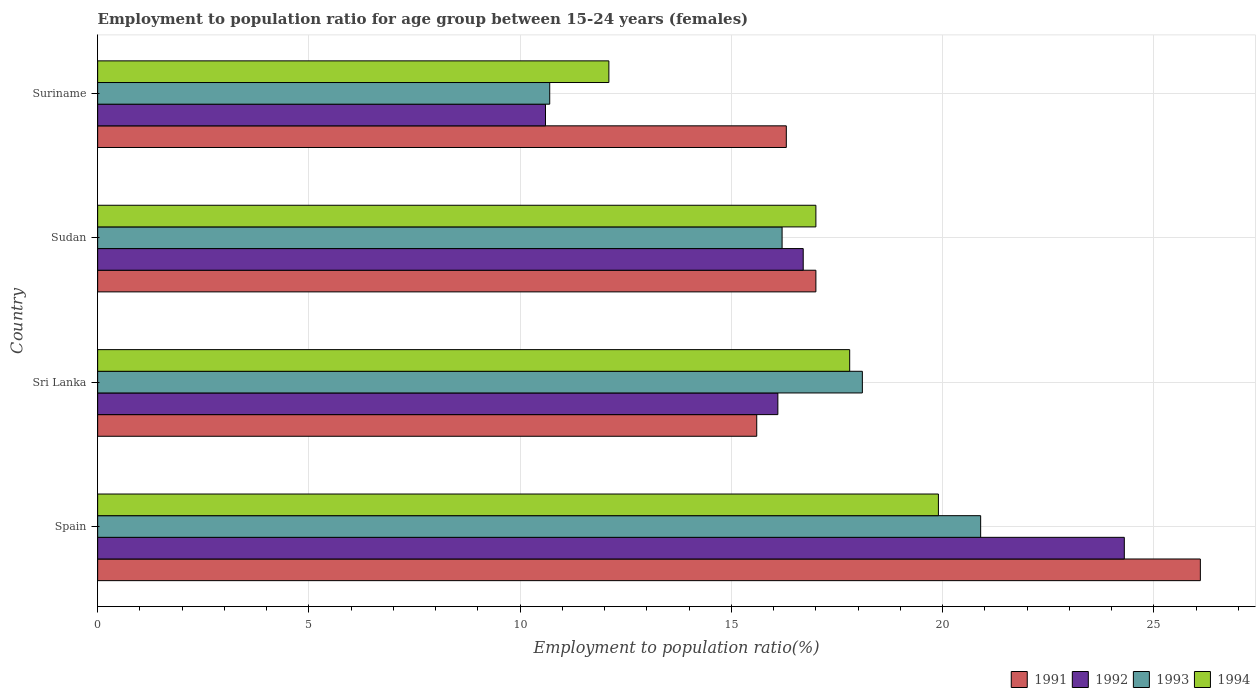How many different coloured bars are there?
Offer a very short reply. 4. Are the number of bars on each tick of the Y-axis equal?
Give a very brief answer. Yes. What is the label of the 2nd group of bars from the top?
Your response must be concise. Sudan. In how many cases, is the number of bars for a given country not equal to the number of legend labels?
Provide a succinct answer. 0. What is the employment to population ratio in 1994 in Sri Lanka?
Ensure brevity in your answer.  17.8. Across all countries, what is the maximum employment to population ratio in 1991?
Provide a succinct answer. 26.1. Across all countries, what is the minimum employment to population ratio in 1991?
Your answer should be compact. 15.6. In which country was the employment to population ratio in 1994 maximum?
Your answer should be compact. Spain. In which country was the employment to population ratio in 1994 minimum?
Offer a very short reply. Suriname. What is the total employment to population ratio in 1992 in the graph?
Make the answer very short. 67.7. What is the difference between the employment to population ratio in 1993 in Spain and that in Sri Lanka?
Ensure brevity in your answer.  2.8. What is the difference between the employment to population ratio in 1991 in Sri Lanka and the employment to population ratio in 1992 in Spain?
Give a very brief answer. -8.7. What is the average employment to population ratio in 1993 per country?
Give a very brief answer. 16.48. What is the difference between the employment to population ratio in 1993 and employment to population ratio in 1994 in Suriname?
Make the answer very short. -1.4. What is the ratio of the employment to population ratio in 1994 in Sudan to that in Suriname?
Ensure brevity in your answer.  1.4. Is the employment to population ratio in 1994 in Spain less than that in Sudan?
Your answer should be very brief. No. What is the difference between the highest and the second highest employment to population ratio in 1993?
Your answer should be very brief. 2.8. What is the difference between the highest and the lowest employment to population ratio in 1991?
Provide a succinct answer. 10.5. What does the 2nd bar from the bottom in Sri Lanka represents?
Your response must be concise. 1992. Are all the bars in the graph horizontal?
Your answer should be compact. Yes. How many countries are there in the graph?
Provide a succinct answer. 4. Does the graph contain grids?
Ensure brevity in your answer.  Yes. Where does the legend appear in the graph?
Offer a terse response. Bottom right. How are the legend labels stacked?
Keep it short and to the point. Horizontal. What is the title of the graph?
Give a very brief answer. Employment to population ratio for age group between 15-24 years (females). What is the label or title of the X-axis?
Provide a short and direct response. Employment to population ratio(%). What is the Employment to population ratio(%) of 1991 in Spain?
Offer a very short reply. 26.1. What is the Employment to population ratio(%) in 1992 in Spain?
Make the answer very short. 24.3. What is the Employment to population ratio(%) in 1993 in Spain?
Make the answer very short. 20.9. What is the Employment to population ratio(%) in 1994 in Spain?
Provide a short and direct response. 19.9. What is the Employment to population ratio(%) in 1991 in Sri Lanka?
Ensure brevity in your answer.  15.6. What is the Employment to population ratio(%) of 1992 in Sri Lanka?
Make the answer very short. 16.1. What is the Employment to population ratio(%) in 1993 in Sri Lanka?
Keep it short and to the point. 18.1. What is the Employment to population ratio(%) of 1994 in Sri Lanka?
Make the answer very short. 17.8. What is the Employment to population ratio(%) in 1991 in Sudan?
Make the answer very short. 17. What is the Employment to population ratio(%) of 1992 in Sudan?
Keep it short and to the point. 16.7. What is the Employment to population ratio(%) in 1993 in Sudan?
Make the answer very short. 16.2. What is the Employment to population ratio(%) of 1991 in Suriname?
Make the answer very short. 16.3. What is the Employment to population ratio(%) of 1992 in Suriname?
Keep it short and to the point. 10.6. What is the Employment to population ratio(%) of 1993 in Suriname?
Your answer should be compact. 10.7. What is the Employment to population ratio(%) of 1994 in Suriname?
Provide a short and direct response. 12.1. Across all countries, what is the maximum Employment to population ratio(%) in 1991?
Provide a short and direct response. 26.1. Across all countries, what is the maximum Employment to population ratio(%) of 1992?
Give a very brief answer. 24.3. Across all countries, what is the maximum Employment to population ratio(%) of 1993?
Make the answer very short. 20.9. Across all countries, what is the maximum Employment to population ratio(%) in 1994?
Offer a very short reply. 19.9. Across all countries, what is the minimum Employment to population ratio(%) of 1991?
Ensure brevity in your answer.  15.6. Across all countries, what is the minimum Employment to population ratio(%) of 1992?
Keep it short and to the point. 10.6. Across all countries, what is the minimum Employment to population ratio(%) in 1993?
Provide a succinct answer. 10.7. Across all countries, what is the minimum Employment to population ratio(%) in 1994?
Provide a succinct answer. 12.1. What is the total Employment to population ratio(%) of 1991 in the graph?
Offer a very short reply. 75. What is the total Employment to population ratio(%) of 1992 in the graph?
Provide a succinct answer. 67.7. What is the total Employment to population ratio(%) of 1993 in the graph?
Ensure brevity in your answer.  65.9. What is the total Employment to population ratio(%) of 1994 in the graph?
Keep it short and to the point. 66.8. What is the difference between the Employment to population ratio(%) in 1991 in Spain and that in Sudan?
Your response must be concise. 9.1. What is the difference between the Employment to population ratio(%) in 1992 in Spain and that in Sudan?
Provide a short and direct response. 7.6. What is the difference between the Employment to population ratio(%) in 1993 in Spain and that in Sudan?
Offer a very short reply. 4.7. What is the difference between the Employment to population ratio(%) in 1994 in Spain and that in Sudan?
Provide a succinct answer. 2.9. What is the difference between the Employment to population ratio(%) of 1991 in Spain and that in Suriname?
Provide a succinct answer. 9.8. What is the difference between the Employment to population ratio(%) of 1993 in Spain and that in Suriname?
Provide a succinct answer. 10.2. What is the difference between the Employment to population ratio(%) in 1994 in Spain and that in Suriname?
Offer a terse response. 7.8. What is the difference between the Employment to population ratio(%) of 1991 in Sri Lanka and that in Sudan?
Keep it short and to the point. -1.4. What is the difference between the Employment to population ratio(%) of 1991 in Sudan and that in Suriname?
Provide a succinct answer. 0.7. What is the difference between the Employment to population ratio(%) in 1992 in Sudan and that in Suriname?
Offer a very short reply. 6.1. What is the difference between the Employment to population ratio(%) of 1993 in Sudan and that in Suriname?
Provide a short and direct response. 5.5. What is the difference between the Employment to population ratio(%) in 1994 in Sudan and that in Suriname?
Your answer should be very brief. 4.9. What is the difference between the Employment to population ratio(%) of 1991 in Spain and the Employment to population ratio(%) of 1992 in Sri Lanka?
Make the answer very short. 10. What is the difference between the Employment to population ratio(%) of 1991 in Spain and the Employment to population ratio(%) of 1994 in Sri Lanka?
Your answer should be compact. 8.3. What is the difference between the Employment to population ratio(%) of 1992 in Spain and the Employment to population ratio(%) of 1993 in Sri Lanka?
Provide a short and direct response. 6.2. What is the difference between the Employment to population ratio(%) of 1992 in Spain and the Employment to population ratio(%) of 1994 in Sri Lanka?
Provide a succinct answer. 6.5. What is the difference between the Employment to population ratio(%) in 1991 in Spain and the Employment to population ratio(%) in 1994 in Sudan?
Offer a very short reply. 9.1. What is the difference between the Employment to population ratio(%) of 1992 in Spain and the Employment to population ratio(%) of 1993 in Sudan?
Offer a very short reply. 8.1. What is the difference between the Employment to population ratio(%) in 1993 in Spain and the Employment to population ratio(%) in 1994 in Sudan?
Offer a terse response. 3.9. What is the difference between the Employment to population ratio(%) of 1991 in Spain and the Employment to population ratio(%) of 1992 in Suriname?
Your response must be concise. 15.5. What is the difference between the Employment to population ratio(%) in 1991 in Spain and the Employment to population ratio(%) in 1993 in Suriname?
Offer a very short reply. 15.4. What is the difference between the Employment to population ratio(%) in 1991 in Spain and the Employment to population ratio(%) in 1994 in Suriname?
Your answer should be compact. 14. What is the difference between the Employment to population ratio(%) in 1993 in Spain and the Employment to population ratio(%) in 1994 in Suriname?
Ensure brevity in your answer.  8.8. What is the difference between the Employment to population ratio(%) of 1991 in Sri Lanka and the Employment to population ratio(%) of 1992 in Sudan?
Provide a succinct answer. -1.1. What is the difference between the Employment to population ratio(%) of 1991 in Sri Lanka and the Employment to population ratio(%) of 1994 in Sudan?
Offer a very short reply. -1.4. What is the difference between the Employment to population ratio(%) of 1992 in Sri Lanka and the Employment to population ratio(%) of 1993 in Sudan?
Provide a succinct answer. -0.1. What is the difference between the Employment to population ratio(%) of 1993 in Sri Lanka and the Employment to population ratio(%) of 1994 in Sudan?
Keep it short and to the point. 1.1. What is the difference between the Employment to population ratio(%) in 1991 in Sri Lanka and the Employment to population ratio(%) in 1993 in Suriname?
Ensure brevity in your answer.  4.9. What is the difference between the Employment to population ratio(%) in 1991 in Sri Lanka and the Employment to population ratio(%) in 1994 in Suriname?
Your response must be concise. 3.5. What is the difference between the Employment to population ratio(%) of 1992 in Sri Lanka and the Employment to population ratio(%) of 1994 in Suriname?
Offer a very short reply. 4. What is the difference between the Employment to population ratio(%) in 1991 in Sudan and the Employment to population ratio(%) in 1992 in Suriname?
Ensure brevity in your answer.  6.4. What is the difference between the Employment to population ratio(%) in 1991 in Sudan and the Employment to population ratio(%) in 1993 in Suriname?
Offer a terse response. 6.3. What is the difference between the Employment to population ratio(%) of 1991 in Sudan and the Employment to population ratio(%) of 1994 in Suriname?
Give a very brief answer. 4.9. What is the difference between the Employment to population ratio(%) of 1992 in Sudan and the Employment to population ratio(%) of 1994 in Suriname?
Give a very brief answer. 4.6. What is the average Employment to population ratio(%) of 1991 per country?
Your answer should be compact. 18.75. What is the average Employment to population ratio(%) of 1992 per country?
Your response must be concise. 16.93. What is the average Employment to population ratio(%) of 1993 per country?
Your answer should be compact. 16.48. What is the difference between the Employment to population ratio(%) in 1991 and Employment to population ratio(%) in 1992 in Spain?
Offer a terse response. 1.8. What is the difference between the Employment to population ratio(%) in 1991 and Employment to population ratio(%) in 1994 in Spain?
Provide a short and direct response. 6.2. What is the difference between the Employment to population ratio(%) of 1992 and Employment to population ratio(%) of 1994 in Spain?
Make the answer very short. 4.4. What is the difference between the Employment to population ratio(%) in 1991 and Employment to population ratio(%) in 1992 in Sri Lanka?
Provide a short and direct response. -0.5. What is the difference between the Employment to population ratio(%) in 1991 and Employment to population ratio(%) in 1993 in Sri Lanka?
Give a very brief answer. -2.5. What is the difference between the Employment to population ratio(%) in 1992 and Employment to population ratio(%) in 1993 in Sri Lanka?
Your response must be concise. -2. What is the difference between the Employment to population ratio(%) in 1992 and Employment to population ratio(%) in 1994 in Sri Lanka?
Your answer should be very brief. -1.7. What is the difference between the Employment to population ratio(%) of 1991 and Employment to population ratio(%) of 1992 in Sudan?
Give a very brief answer. 0.3. What is the difference between the Employment to population ratio(%) in 1991 and Employment to population ratio(%) in 1993 in Sudan?
Your answer should be compact. 0.8. What is the difference between the Employment to population ratio(%) in 1991 and Employment to population ratio(%) in 1994 in Sudan?
Give a very brief answer. 0. What is the difference between the Employment to population ratio(%) of 1992 and Employment to population ratio(%) of 1993 in Sudan?
Ensure brevity in your answer.  0.5. What is the difference between the Employment to population ratio(%) in 1991 and Employment to population ratio(%) in 1992 in Suriname?
Make the answer very short. 5.7. What is the difference between the Employment to population ratio(%) of 1991 and Employment to population ratio(%) of 1993 in Suriname?
Your answer should be very brief. 5.6. What is the ratio of the Employment to population ratio(%) of 1991 in Spain to that in Sri Lanka?
Your answer should be very brief. 1.67. What is the ratio of the Employment to population ratio(%) of 1992 in Spain to that in Sri Lanka?
Offer a terse response. 1.51. What is the ratio of the Employment to population ratio(%) in 1993 in Spain to that in Sri Lanka?
Ensure brevity in your answer.  1.15. What is the ratio of the Employment to population ratio(%) in 1994 in Spain to that in Sri Lanka?
Offer a very short reply. 1.12. What is the ratio of the Employment to population ratio(%) in 1991 in Spain to that in Sudan?
Your answer should be very brief. 1.54. What is the ratio of the Employment to population ratio(%) of 1992 in Spain to that in Sudan?
Ensure brevity in your answer.  1.46. What is the ratio of the Employment to population ratio(%) in 1993 in Spain to that in Sudan?
Offer a very short reply. 1.29. What is the ratio of the Employment to population ratio(%) of 1994 in Spain to that in Sudan?
Provide a short and direct response. 1.17. What is the ratio of the Employment to population ratio(%) of 1991 in Spain to that in Suriname?
Provide a succinct answer. 1.6. What is the ratio of the Employment to population ratio(%) of 1992 in Spain to that in Suriname?
Your answer should be very brief. 2.29. What is the ratio of the Employment to population ratio(%) in 1993 in Spain to that in Suriname?
Your answer should be very brief. 1.95. What is the ratio of the Employment to population ratio(%) in 1994 in Spain to that in Suriname?
Offer a terse response. 1.64. What is the ratio of the Employment to population ratio(%) in 1991 in Sri Lanka to that in Sudan?
Offer a very short reply. 0.92. What is the ratio of the Employment to population ratio(%) of 1992 in Sri Lanka to that in Sudan?
Make the answer very short. 0.96. What is the ratio of the Employment to population ratio(%) in 1993 in Sri Lanka to that in Sudan?
Provide a short and direct response. 1.12. What is the ratio of the Employment to population ratio(%) in 1994 in Sri Lanka to that in Sudan?
Your response must be concise. 1.05. What is the ratio of the Employment to population ratio(%) of 1991 in Sri Lanka to that in Suriname?
Your response must be concise. 0.96. What is the ratio of the Employment to population ratio(%) of 1992 in Sri Lanka to that in Suriname?
Ensure brevity in your answer.  1.52. What is the ratio of the Employment to population ratio(%) of 1993 in Sri Lanka to that in Suriname?
Provide a succinct answer. 1.69. What is the ratio of the Employment to population ratio(%) of 1994 in Sri Lanka to that in Suriname?
Your response must be concise. 1.47. What is the ratio of the Employment to population ratio(%) in 1991 in Sudan to that in Suriname?
Keep it short and to the point. 1.04. What is the ratio of the Employment to population ratio(%) in 1992 in Sudan to that in Suriname?
Make the answer very short. 1.58. What is the ratio of the Employment to population ratio(%) of 1993 in Sudan to that in Suriname?
Offer a very short reply. 1.51. What is the ratio of the Employment to population ratio(%) in 1994 in Sudan to that in Suriname?
Make the answer very short. 1.41. What is the difference between the highest and the second highest Employment to population ratio(%) of 1992?
Give a very brief answer. 7.6. What is the difference between the highest and the second highest Employment to population ratio(%) in 1993?
Ensure brevity in your answer.  2.8. What is the difference between the highest and the second highest Employment to population ratio(%) in 1994?
Offer a terse response. 2.1. What is the difference between the highest and the lowest Employment to population ratio(%) of 1991?
Provide a succinct answer. 10.5. What is the difference between the highest and the lowest Employment to population ratio(%) in 1994?
Give a very brief answer. 7.8. 